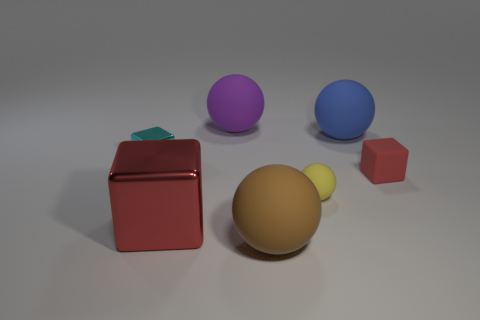Subtract all large brown spheres. How many spheres are left? 3 Add 2 green shiny objects. How many objects exist? 9 Subtract all brown spheres. How many spheres are left? 3 Subtract all green balls. How many red blocks are left? 2 Subtract all cubes. How many objects are left? 4 Subtract all purple balls. Subtract all gray cylinders. How many balls are left? 3 Subtract all cyan blocks. Subtract all big gray balls. How many objects are left? 6 Add 2 large metal cubes. How many large metal cubes are left? 3 Add 1 big rubber objects. How many big rubber objects exist? 4 Subtract 0 blue cylinders. How many objects are left? 7 